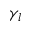Convert formula to latex. <formula><loc_0><loc_0><loc_500><loc_500>\gamma _ { l }</formula> 